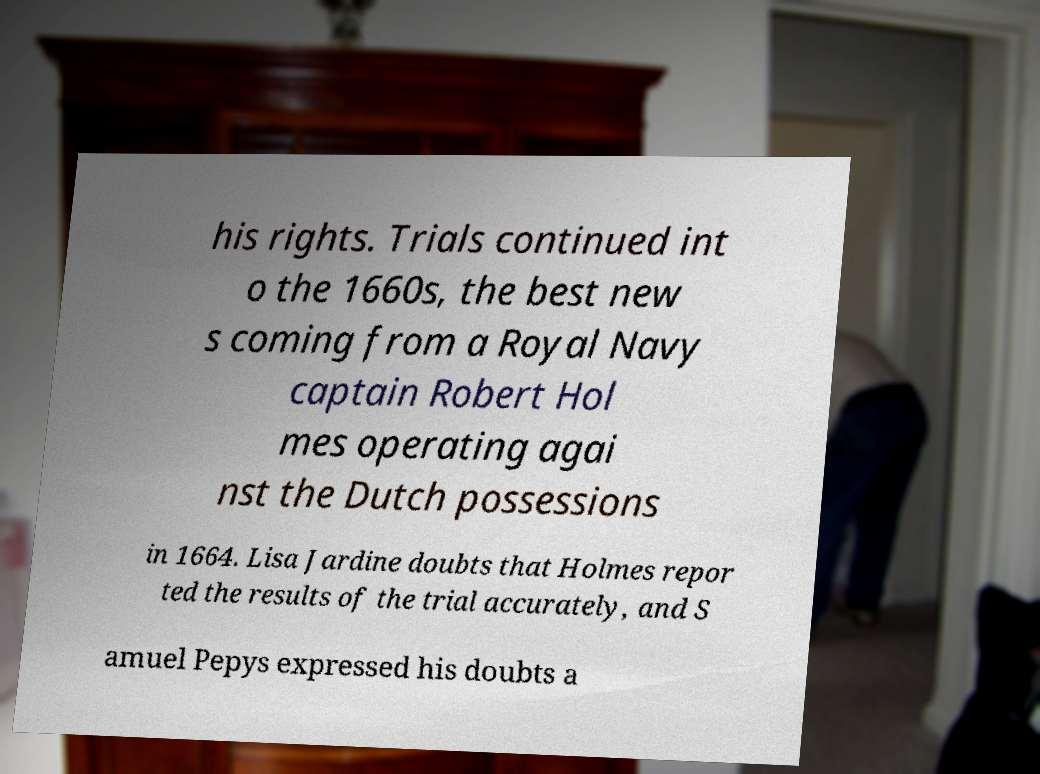There's text embedded in this image that I need extracted. Can you transcribe it verbatim? his rights. Trials continued int o the 1660s, the best new s coming from a Royal Navy captain Robert Hol mes operating agai nst the Dutch possessions in 1664. Lisa Jardine doubts that Holmes repor ted the results of the trial accurately, and S amuel Pepys expressed his doubts a 